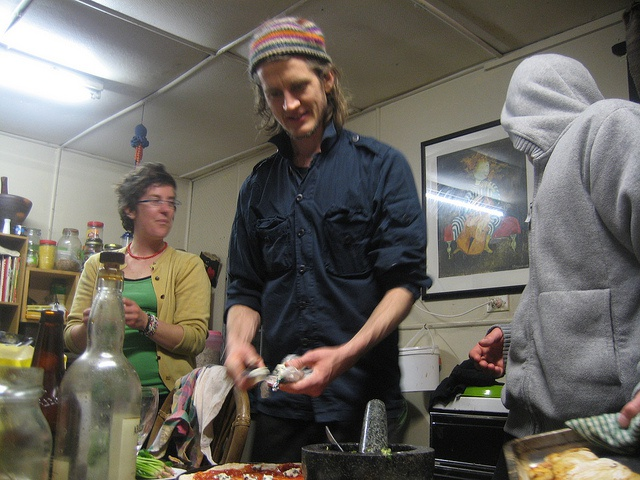Describe the objects in this image and their specific colors. I can see people in lavender, black, tan, and gray tones, people in lavender, gray, darkgray, black, and lightgray tones, people in lavender, tan, gray, and black tones, bottle in lavender, gray, black, and darkgreen tones, and oven in lavender, black, darkgray, gray, and navy tones in this image. 